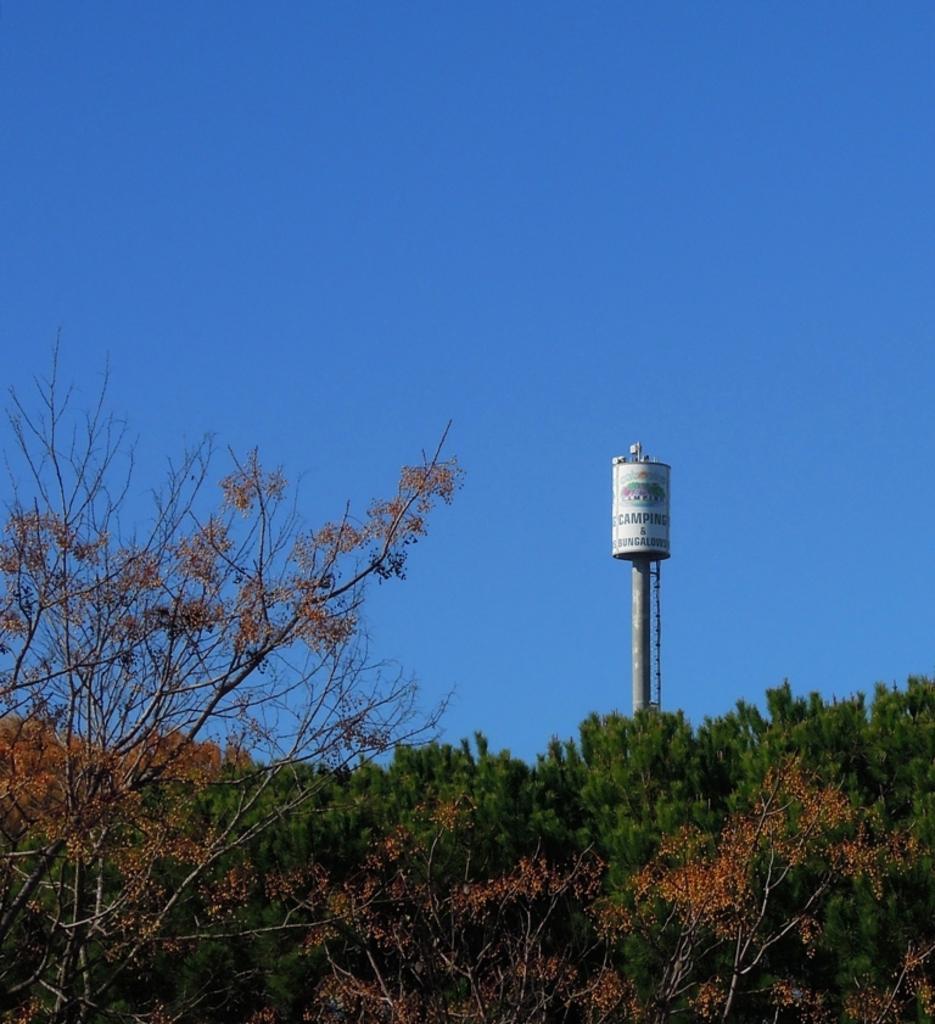Can you describe this image briefly? In this image i can see the trees, near there is a water tower, at the top i can see the sky. 